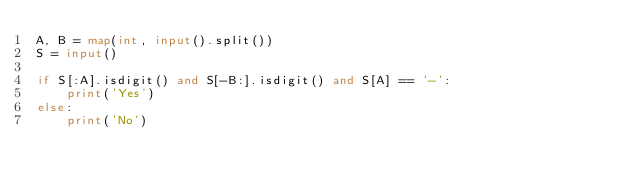<code> <loc_0><loc_0><loc_500><loc_500><_Python_>A, B = map(int, input().split())
S = input()

if S[:A].isdigit() and S[-B:].isdigit() and S[A] == '-':
    print('Yes')
else:
    print('No')
</code> 